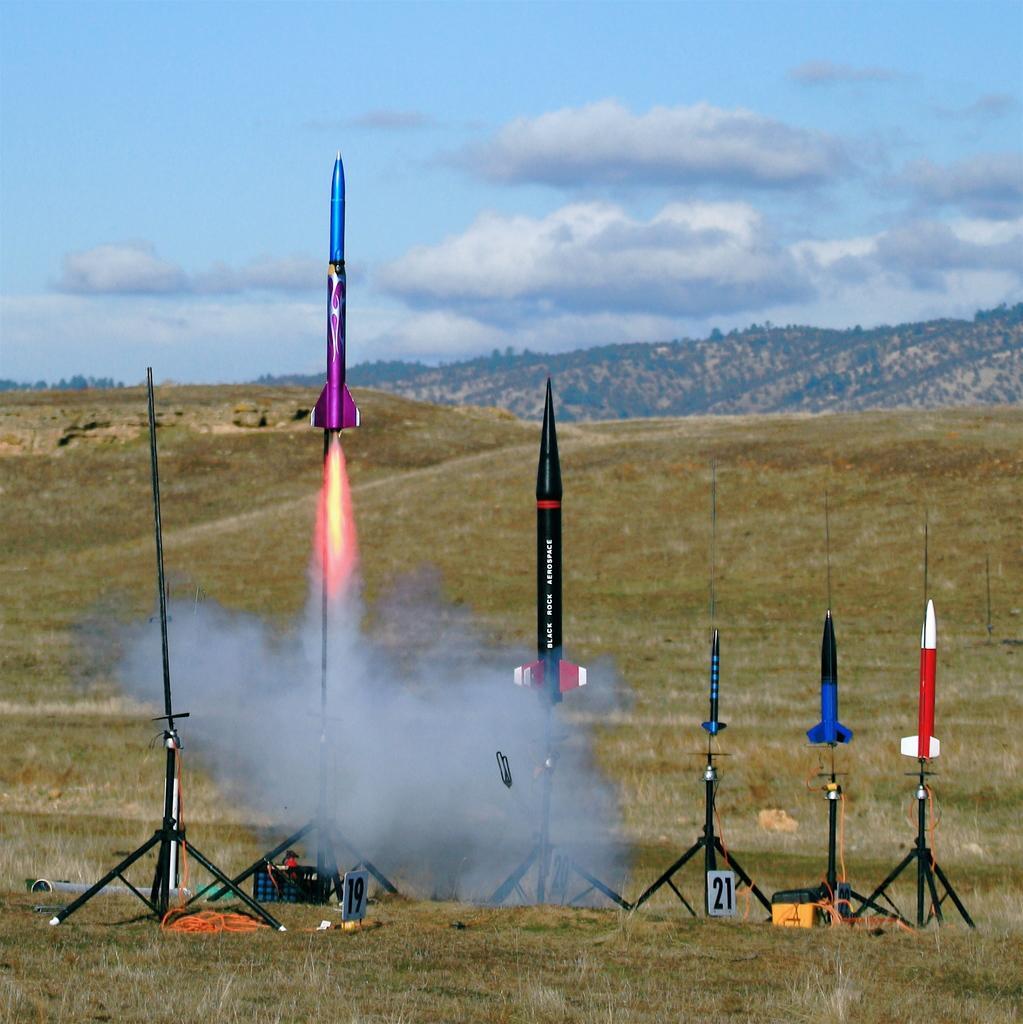Please provide a concise description of this image. In this image there are five rockets kept one beside the other. The rocket on the left side has started to fly in to the sky as it is emitting the fire. The other four rockets are beside it. In the background there are hills on which there are trees. At the top there is sky. At the bottom there is grass and wires. 